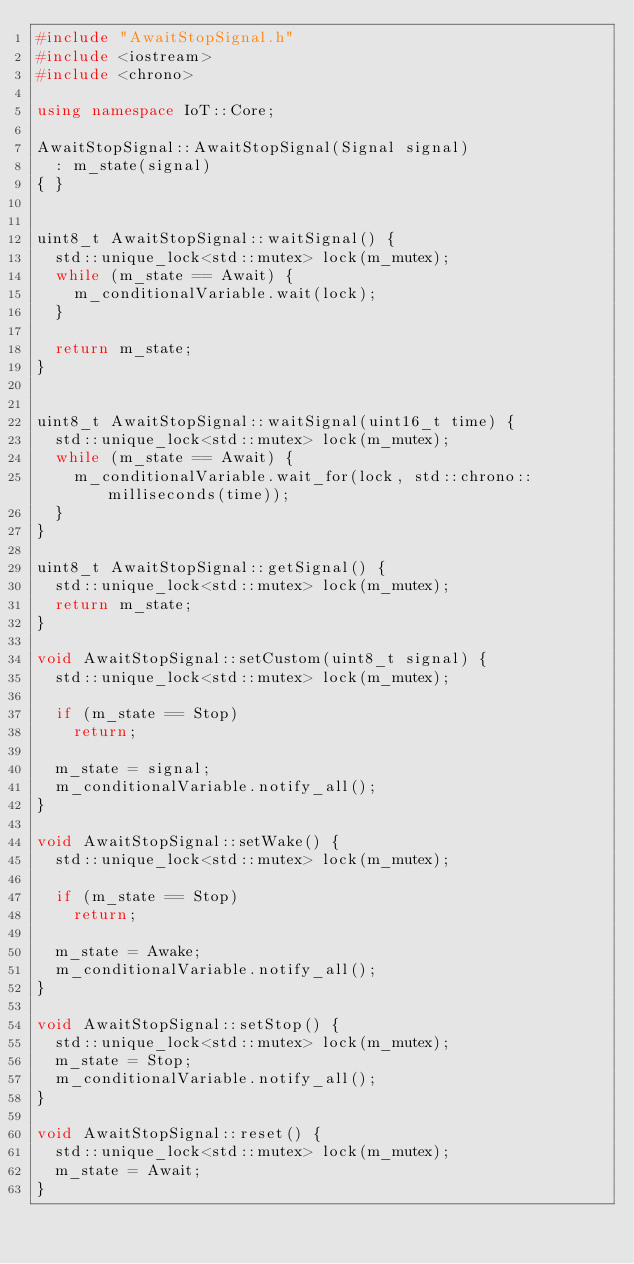Convert code to text. <code><loc_0><loc_0><loc_500><loc_500><_C++_>#include "AwaitStopSignal.h"
#include <iostream>
#include <chrono>

using namespace IoT::Core;

AwaitStopSignal::AwaitStopSignal(Signal signal)
	: m_state(signal)
{ }


uint8_t AwaitStopSignal::waitSignal() {
	std::unique_lock<std::mutex> lock(m_mutex);
	while (m_state == Await) {
		m_conditionalVariable.wait(lock);
	}

	return m_state;
}


uint8_t AwaitStopSignal::waitSignal(uint16_t time) {
	std::unique_lock<std::mutex> lock(m_mutex);
	while (m_state == Await) {
		m_conditionalVariable.wait_for(lock, std::chrono::milliseconds(time));
	}
}

uint8_t AwaitStopSignal::getSignal() {
	std::unique_lock<std::mutex> lock(m_mutex);
	return m_state;
}

void AwaitStopSignal::setCustom(uint8_t signal) {
	std::unique_lock<std::mutex> lock(m_mutex);

	if (m_state == Stop)
		return;

	m_state = signal;
	m_conditionalVariable.notify_all();
}

void AwaitStopSignal::setWake() {
	std::unique_lock<std::mutex> lock(m_mutex);

	if (m_state == Stop)
		return;

	m_state = Awake;
	m_conditionalVariable.notify_all();
}

void AwaitStopSignal::setStop() {
	std::unique_lock<std::mutex> lock(m_mutex);
	m_state = Stop;
	m_conditionalVariable.notify_all();
}

void AwaitStopSignal::reset() {
	std::unique_lock<std::mutex> lock(m_mutex);
	m_state = Await;
}
</code> 